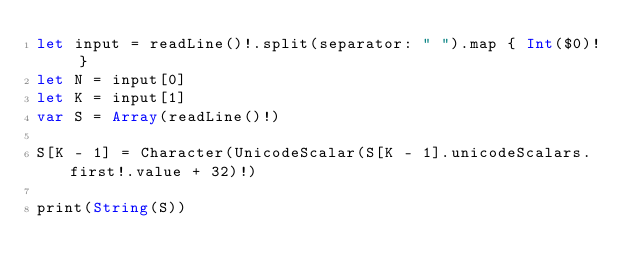<code> <loc_0><loc_0><loc_500><loc_500><_Swift_>let input = readLine()!.split(separator: " ").map { Int($0)! }
let N = input[0]
let K = input[1]
var S = Array(readLine()!)

S[K - 1] = Character(UnicodeScalar(S[K - 1].unicodeScalars.first!.value + 32)!)

print(String(S))
</code> 